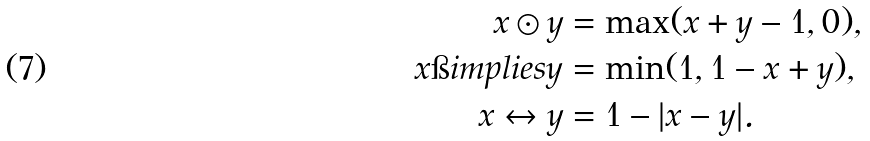<formula> <loc_0><loc_0><loc_500><loc_500>x \odot y & = \max ( x + y - 1 , 0 ) , \\ x \i i m p l i e s y & = \min ( 1 , 1 - x + y ) , \\ x \leftrightarrow y & = 1 - | x - y | .</formula> 